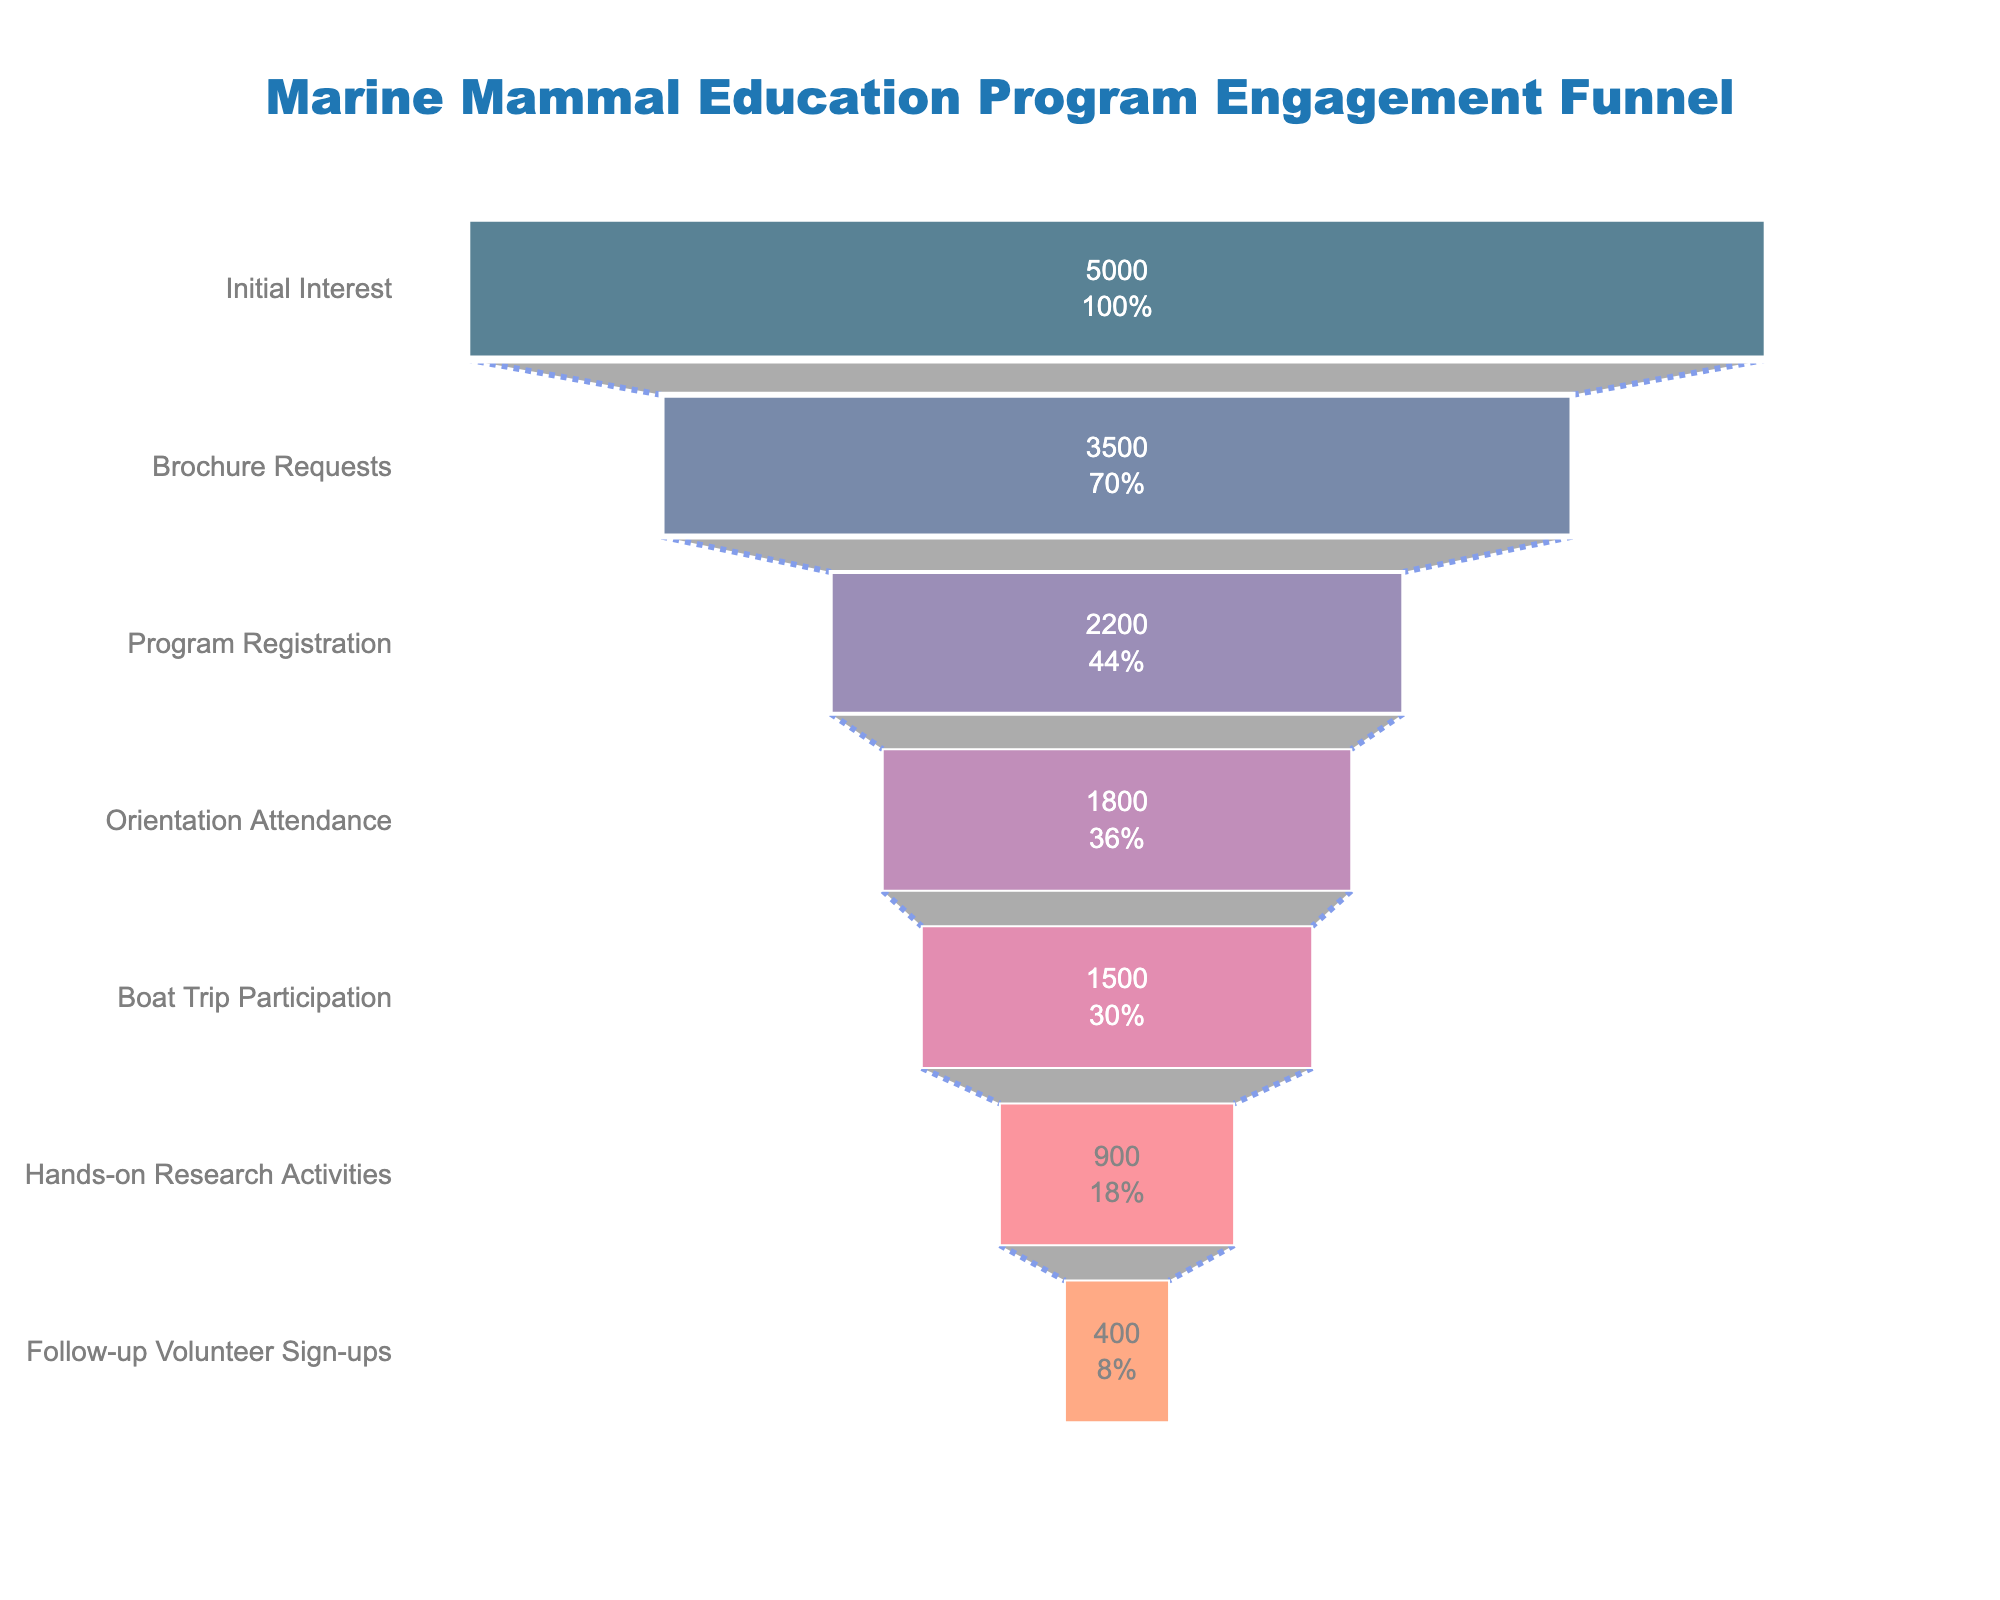what is the title of the figure? The title is typically at the top of the chart, central and formatted in larger text.
Answer: Marine Mammal Education Program Engagement Funnel What is the total number of visitors who showed initial interest? This information can be found at the top stage of the funnel chart.
Answer: 5000 How many visitors engaged in hands-on research activities? The number of visitors is shown inside the corresponding segment of the funnel chart.
Answer: 900 What percentage of initial interest visitors participated in a boat trip? The percentage is displayed with the number inside the "Boat Trip Participation" stage.
Answer: 30% Between which stages does the largest drop-off in visitor numbers occur? The largest drop-off can be identified by visually comparing the widths of each segment in the funnel and deducing where the difference is the largest.
Answer: Program Registration to Orientation Attendance How many more visitors attended the orientation than participated in hands-on research activities? Subtract the number of visitors at the "Hands-on Research Activities" stage from those at the "Orientation Attendance" stage (1800 - 900).
Answer: 900 What is the difference in visitors between the "Brochure Requests" and "Program Registration" stages? Subtract the number of visitors at the "Program Registration" stage from those at the "Brochure Requests" stage (3500 - 2200).
Answer: 1300 Which stage had the highest number of visitors? Look at the segment with the largest width at the top of the funnel.
Answer: Initial Interest What percentage of boat trip participants signed up for follow-up volunteer activities? This can be calculated by (number of follow-up volunteer sign-ups / number of boat trip participants) * 100. (400 / 1500) * 100 = 26.67%
Answer: 26.67% Is the participation in hands-on research activities less than half of the initial interest visitors? Compare the number of hands-on research activity participants (900) with half the initial interest visitors (5000 / 2 = 2500).
Answer: Yes 